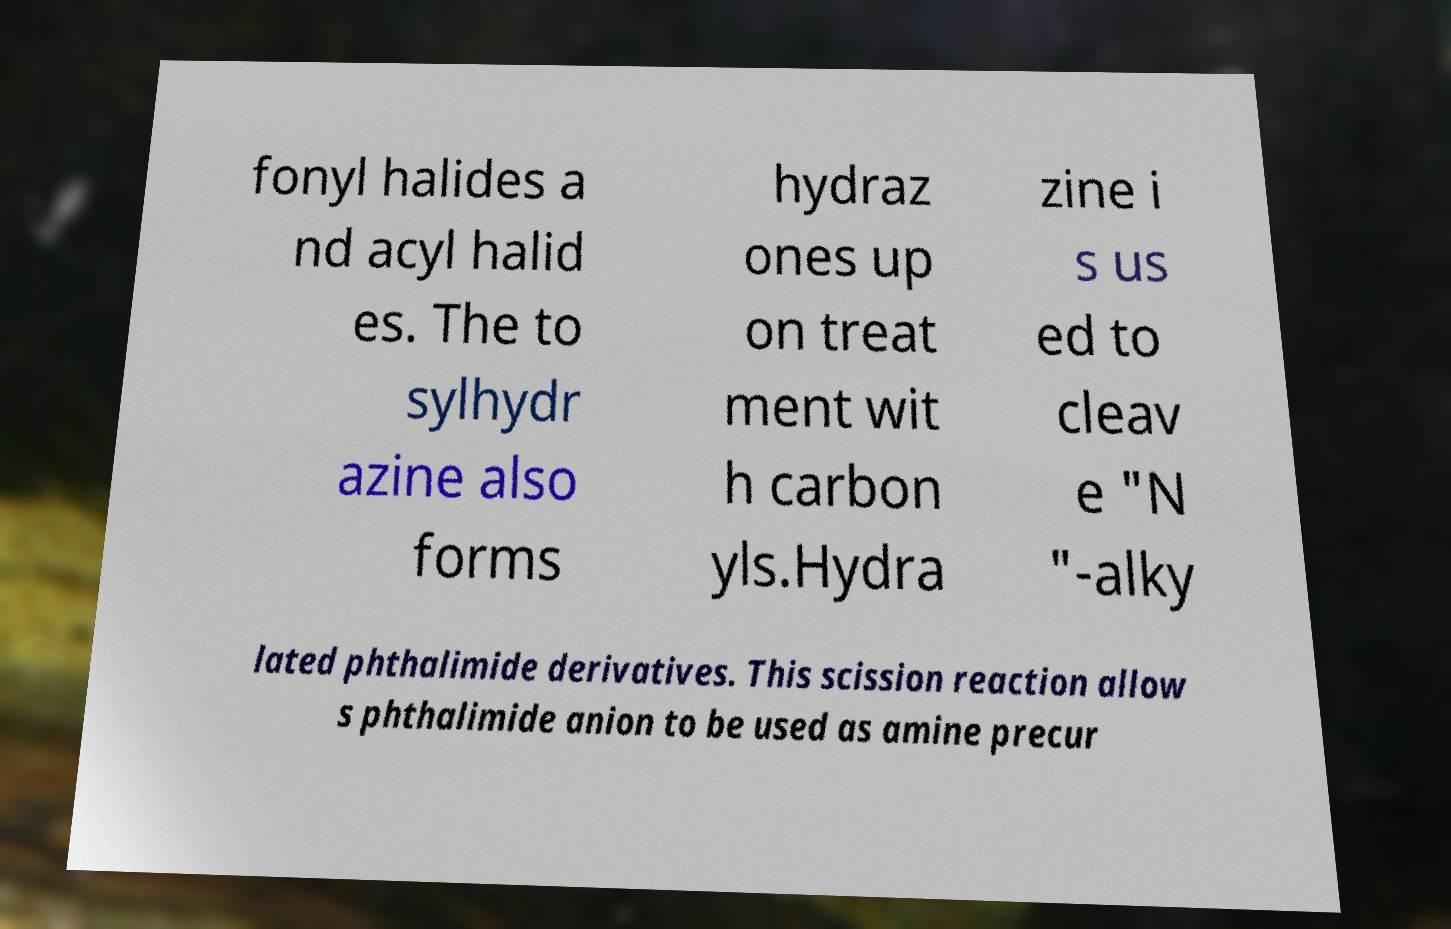I need the written content from this picture converted into text. Can you do that? fonyl halides a nd acyl halid es. The to sylhydr azine also forms hydraz ones up on treat ment wit h carbon yls.Hydra zine i s us ed to cleav e "N "-alky lated phthalimide derivatives. This scission reaction allow s phthalimide anion to be used as amine precur 